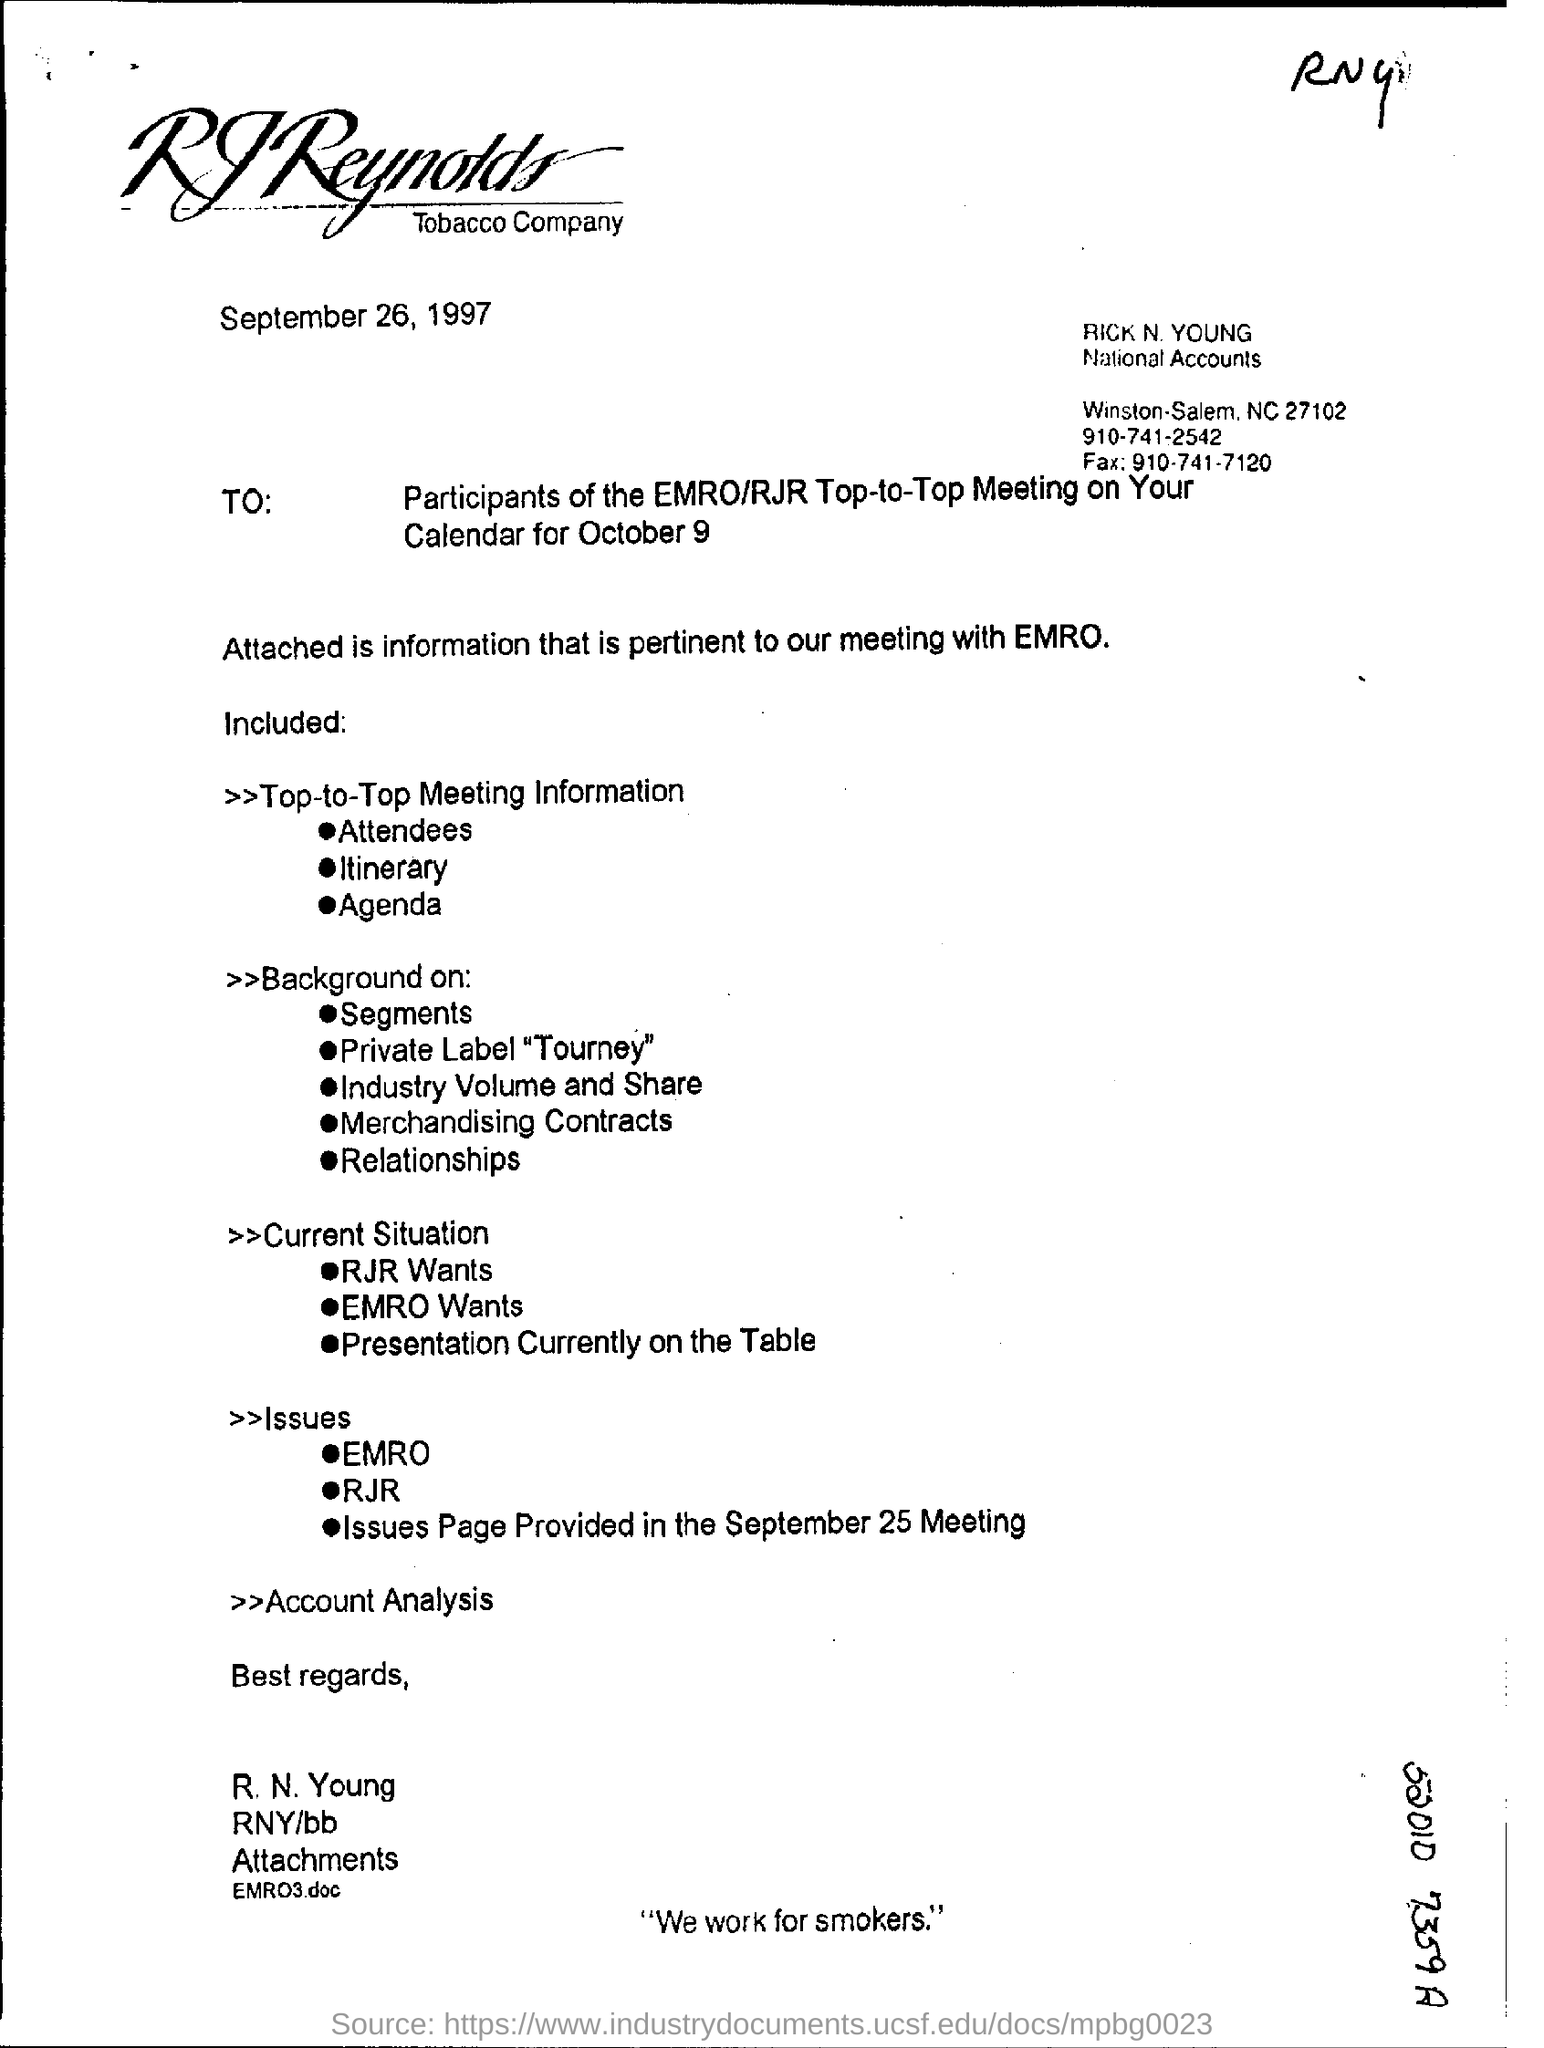What is the date mentioned in this document?
Make the answer very short. September 26, 1997. What is the date mentioned in the top of the document ?
Make the answer very short. September 26, 1997. What is the Fax Number ?
Provide a short and direct response. 910-741-7120. 